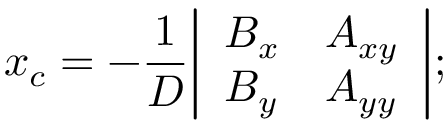<formula> <loc_0><loc_0><loc_500><loc_500>x _ { c } = - { \frac { 1 } { D } } { \left | \begin{array} { l l } { B _ { x } } & { A _ { x y } } \\ { B _ { y } } & { A _ { y y } } \end{array} \right | } ;</formula> 